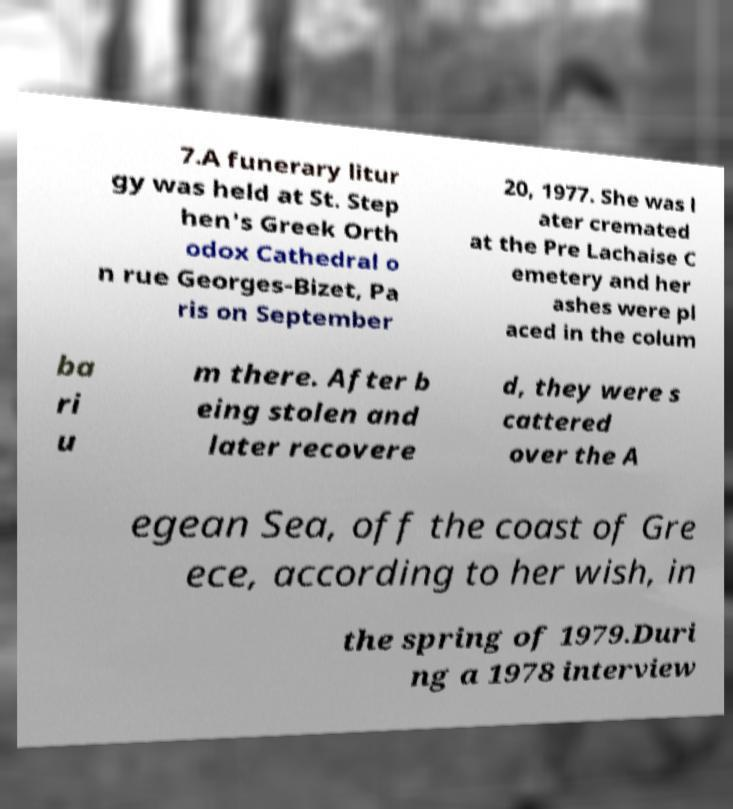Please identify and transcribe the text found in this image. 7.A funerary litur gy was held at St. Step hen's Greek Orth odox Cathedral o n rue Georges-Bizet, Pa ris on September 20, 1977. She was l ater cremated at the Pre Lachaise C emetery and her ashes were pl aced in the colum ba ri u m there. After b eing stolen and later recovere d, they were s cattered over the A egean Sea, off the coast of Gre ece, according to her wish, in the spring of 1979.Duri ng a 1978 interview 